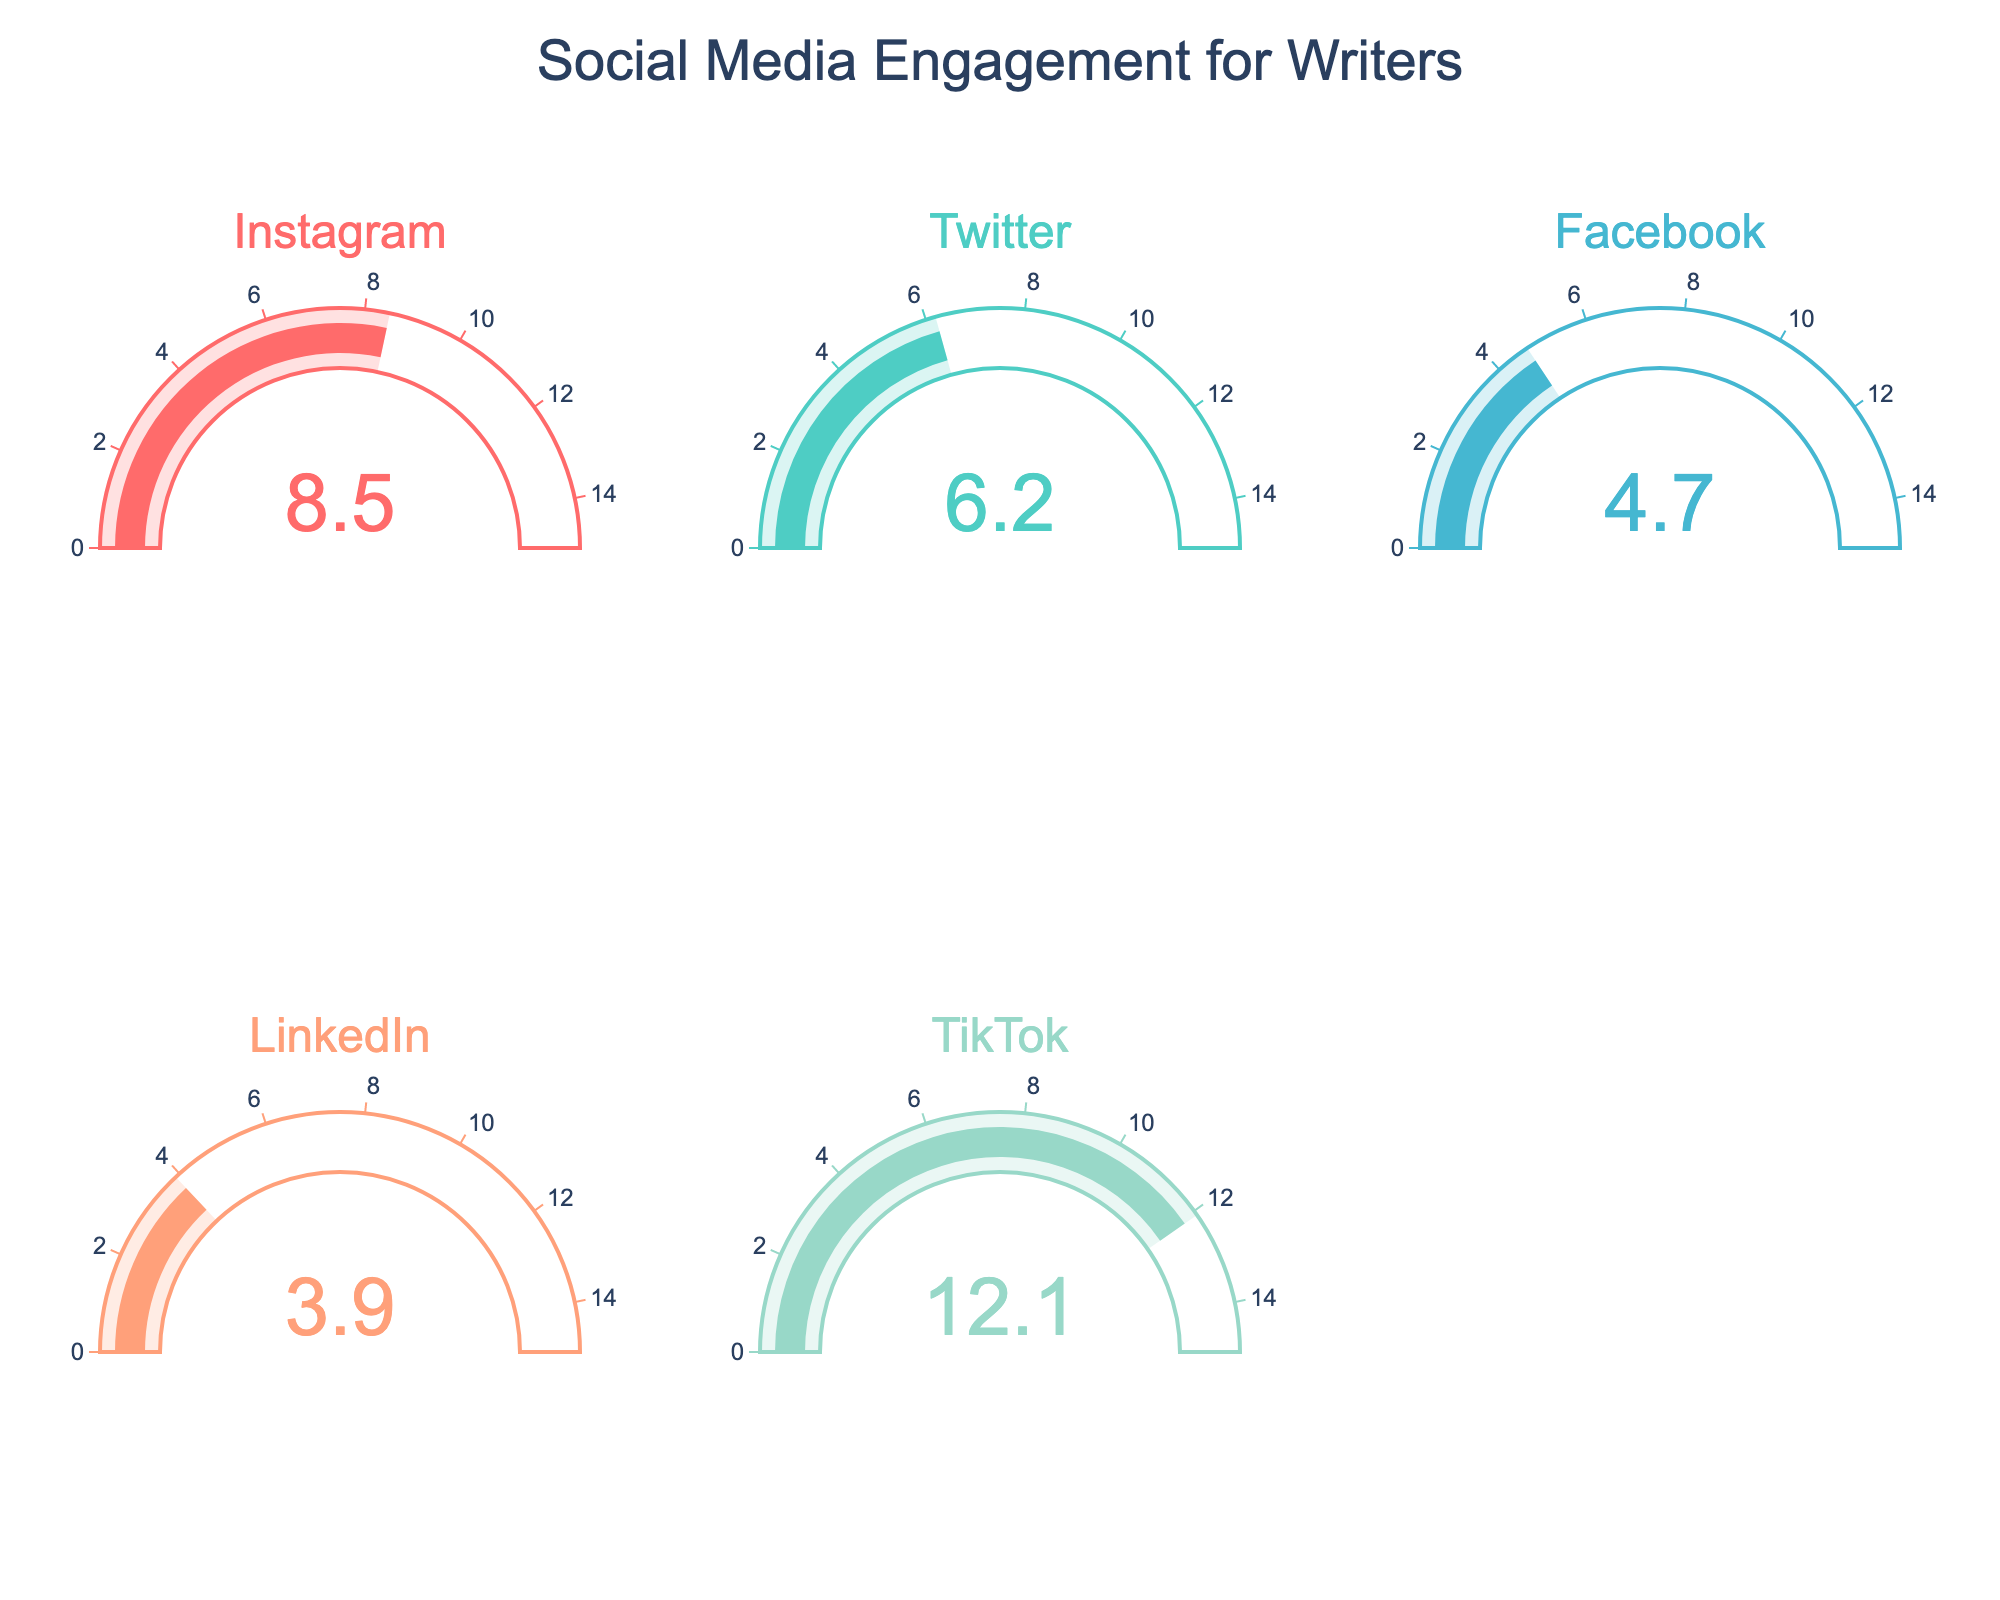Which social media platform has the highest engagement percentage? The gauge for TikTok shows an engagement percentage of 12.1, which is the highest among all platforms displayed.
Answer: TikTok What's the engagement percentage for Instagram? The Instagram gauge shows a value of 8.5, which represents its engagement percentage.
Answer: 8.5 What is the sum of the engagement percentages for LinkedIn and Facebook? The engagement percentage for LinkedIn is 3.9, and for Facebook, it is 4.7. Adding these together, 3.9 + 4.7 = 8.6.
Answer: 8.6 How much greater is TikTok's engagement percentage than Twitter's? TikTok's engagement percentage is 12.1 and Twitter's is 6.2. The difference is 12.1 - 6.2 = 5.9.
Answer: 5.9 Which platform has the lowest engagement percentage? The LinkedIn gauge shows the lowest engagement percentage, which is 3.9.
Answer: LinkedIn What is the average engagement percentage across all social media platforms shown? Add all the engagement percentages together: 8.5 (Instagram) + 6.2 (Twitter) + 4.7 (Facebook) + 3.9 (LinkedIn) + 12.1 (TikTok) = 35.4. Then, divide by the number of platforms (5): 35.4 / 5 = 7.08.
Answer: 7.08 If the engagement percentage on Instagram increased by 2 points, what would it be? The current engagement percentage on Instagram is 8.5. If it increased by 2 points, the new engagement percentage would be 8.5 + 2 = 10.5.
Answer: 10.5 How much higher is Instagram's engagement percentage compared to LinkedIn's? Instagram's engagement percentage is 8.5, and LinkedIn's is 3.9. The difference is 8.5 - 3.9 = 4.6.
Answer: 4.6 What’s the key color used for Facebook’s gauge chart? The primary color for Facebook's gauge is shown as a shade of peach (#FFA07A).
Answer: Peach 